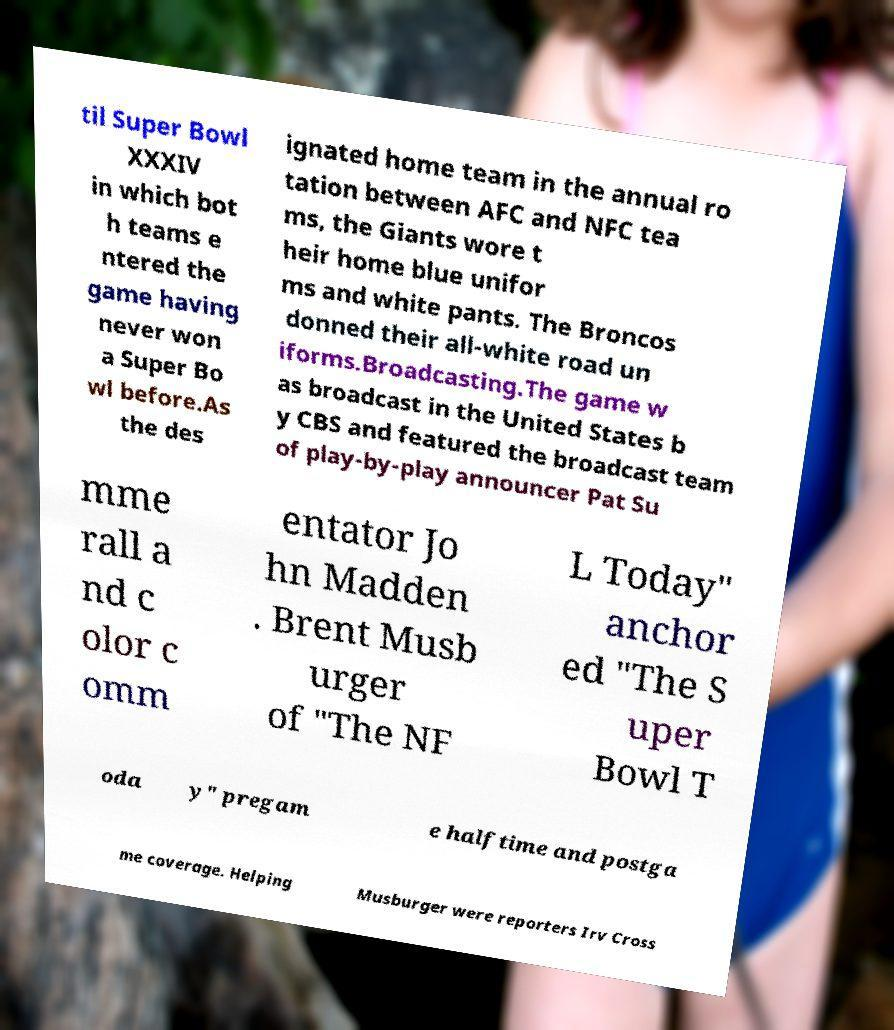Please read and relay the text visible in this image. What does it say? til Super Bowl XXXIV in which bot h teams e ntered the game having never won a Super Bo wl before.As the des ignated home team in the annual ro tation between AFC and NFC tea ms, the Giants wore t heir home blue unifor ms and white pants. The Broncos donned their all-white road un iforms.Broadcasting.The game w as broadcast in the United States b y CBS and featured the broadcast team of play-by-play announcer Pat Su mme rall a nd c olor c omm entator Jo hn Madden . Brent Musb urger of "The NF L Today" anchor ed "The S uper Bowl T oda y" pregam e halftime and postga me coverage. Helping Musburger were reporters Irv Cross 